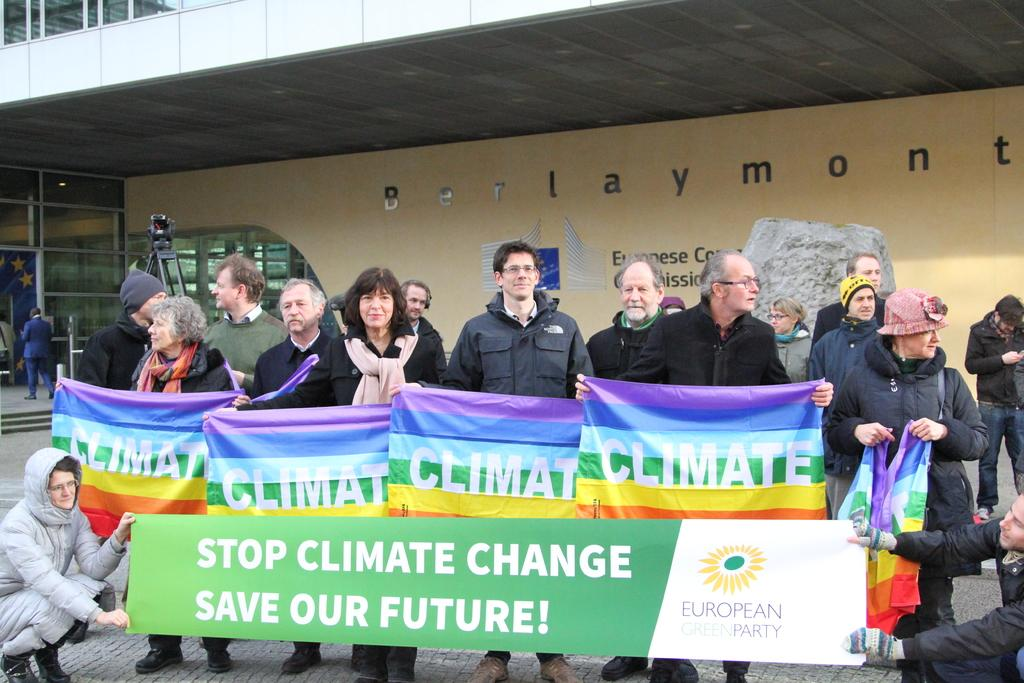What are the people in the image doing? The people in the image are standing and holding banners. Are there any other people in the image with a different posture? Yes, there are people sitting in the image, and they are holding a board. What can be seen in the background of the image? In the background, there is a wall, a tripod, and a flag. How many people are visible in the image? There are people standing, sitting, and in the background, so it is difficult to provide an exact count. What type of shade is provided by the worm in the image? There is no worm present in the image, so no shade can be provided by a worm. 